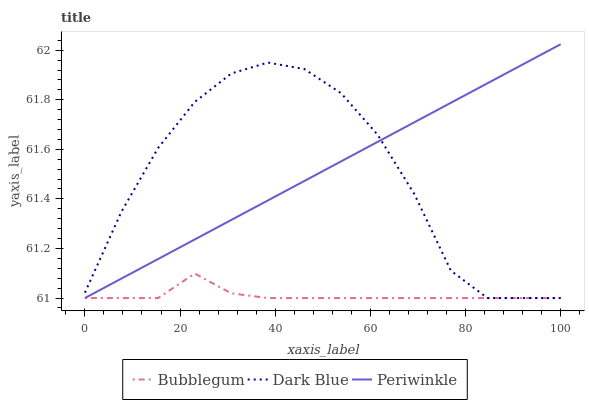Does Bubblegum have the minimum area under the curve?
Answer yes or no. Yes. Does Periwinkle have the maximum area under the curve?
Answer yes or no. Yes. Does Periwinkle have the minimum area under the curve?
Answer yes or no. No. Does Bubblegum have the maximum area under the curve?
Answer yes or no. No. Is Periwinkle the smoothest?
Answer yes or no. Yes. Is Dark Blue the roughest?
Answer yes or no. Yes. Is Bubblegum the smoothest?
Answer yes or no. No. Is Bubblegum the roughest?
Answer yes or no. No. Does Dark Blue have the lowest value?
Answer yes or no. Yes. Does Periwinkle have the highest value?
Answer yes or no. Yes. Does Bubblegum have the highest value?
Answer yes or no. No. Does Dark Blue intersect Periwinkle?
Answer yes or no. Yes. Is Dark Blue less than Periwinkle?
Answer yes or no. No. Is Dark Blue greater than Periwinkle?
Answer yes or no. No. 